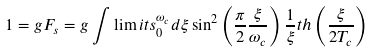<formula> <loc_0><loc_0><loc_500><loc_500>1 = g F _ { s } = g \int \lim i t s _ { 0 } ^ { \omega _ { c } } d { \xi } \sin ^ { 2 } \left ( \frac { \pi } { 2 } \frac { \xi } { \omega _ { c } } \right ) \frac { 1 } { \xi } t h \left ( \frac { \xi } { 2 T _ { c } } \right )</formula> 